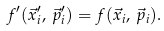<formula> <loc_0><loc_0><loc_500><loc_500>f ^ { \prime } ( \vec { x } ^ { \prime } _ { i } , \, \vec { p } ^ { \prime } _ { i } ) = f ( \vec { x } _ { i } , \, \vec { p } _ { i } ) .</formula> 